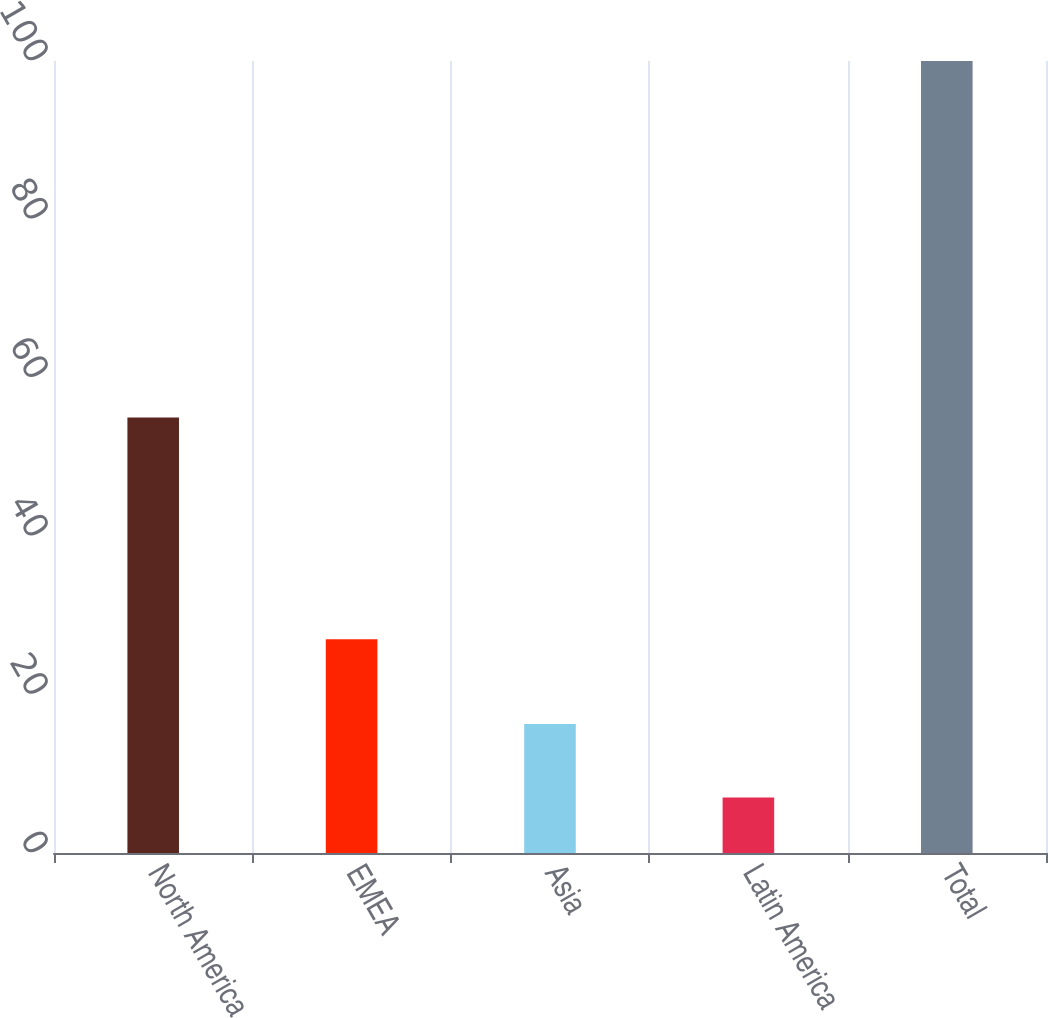Convert chart. <chart><loc_0><loc_0><loc_500><loc_500><bar_chart><fcel>North America<fcel>EMEA<fcel>Asia<fcel>Latin America<fcel>Total<nl><fcel>55<fcel>27<fcel>16.3<fcel>7<fcel>100<nl></chart> 